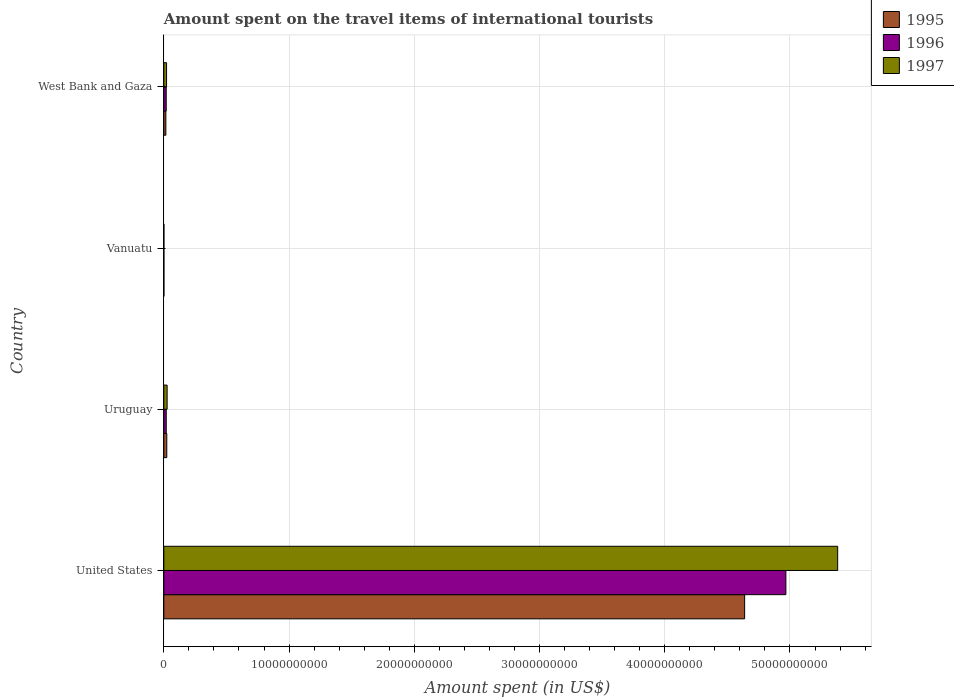How many different coloured bars are there?
Ensure brevity in your answer.  3. Are the number of bars per tick equal to the number of legend labels?
Your answer should be very brief. Yes. Are the number of bars on each tick of the Y-axis equal?
Your answer should be compact. Yes. How many bars are there on the 1st tick from the top?
Keep it short and to the point. 3. How many bars are there on the 4th tick from the bottom?
Provide a short and direct response. 3. What is the amount spent on the travel items of international tourists in 1997 in West Bank and Gaza?
Your answer should be compact. 2.18e+08. Across all countries, what is the maximum amount spent on the travel items of international tourists in 1997?
Make the answer very short. 5.38e+1. In which country was the amount spent on the travel items of international tourists in 1996 maximum?
Offer a very short reply. United States. In which country was the amount spent on the travel items of international tourists in 1995 minimum?
Keep it short and to the point. Vanuatu. What is the total amount spent on the travel items of international tourists in 1996 in the graph?
Provide a succinct answer. 5.01e+1. What is the difference between the amount spent on the travel items of international tourists in 1995 in United States and that in West Bank and Gaza?
Keep it short and to the point. 4.62e+1. What is the difference between the amount spent on the travel items of international tourists in 1995 in Uruguay and the amount spent on the travel items of international tourists in 1996 in Vanuatu?
Your answer should be very brief. 2.31e+08. What is the average amount spent on the travel items of international tourists in 1995 per country?
Your response must be concise. 1.17e+1. What is the difference between the amount spent on the travel items of international tourists in 1996 and amount spent on the travel items of international tourists in 1995 in United States?
Your answer should be compact. 3.29e+09. What is the ratio of the amount spent on the travel items of international tourists in 1997 in United States to that in Vanuatu?
Your response must be concise. 1.08e+04. Is the amount spent on the travel items of international tourists in 1996 in United States less than that in West Bank and Gaza?
Your answer should be very brief. No. What is the difference between the highest and the second highest amount spent on the travel items of international tourists in 1996?
Give a very brief answer. 4.95e+1. What is the difference between the highest and the lowest amount spent on the travel items of international tourists in 1996?
Provide a short and direct response. 4.97e+1. What does the 2nd bar from the top in United States represents?
Offer a very short reply. 1996. What does the 2nd bar from the bottom in Vanuatu represents?
Your answer should be very brief. 1996. Is it the case that in every country, the sum of the amount spent on the travel items of international tourists in 1995 and amount spent on the travel items of international tourists in 1997 is greater than the amount spent on the travel items of international tourists in 1996?
Provide a succinct answer. Yes. How many bars are there?
Ensure brevity in your answer.  12. Are all the bars in the graph horizontal?
Keep it short and to the point. Yes. Where does the legend appear in the graph?
Offer a very short reply. Top right. How many legend labels are there?
Provide a succinct answer. 3. What is the title of the graph?
Give a very brief answer. Amount spent on the travel items of international tourists. Does "1972" appear as one of the legend labels in the graph?
Keep it short and to the point. No. What is the label or title of the X-axis?
Your answer should be very brief. Amount spent (in US$). What is the label or title of the Y-axis?
Give a very brief answer. Country. What is the Amount spent (in US$) in 1995 in United States?
Give a very brief answer. 4.64e+1. What is the Amount spent (in US$) of 1996 in United States?
Offer a terse response. 4.97e+1. What is the Amount spent (in US$) of 1997 in United States?
Make the answer very short. 5.38e+1. What is the Amount spent (in US$) of 1995 in Uruguay?
Keep it short and to the point. 2.36e+08. What is the Amount spent (in US$) in 1996 in Uruguay?
Offer a terse response. 1.92e+08. What is the Amount spent (in US$) in 1997 in Uruguay?
Give a very brief answer. 2.64e+08. What is the Amount spent (in US$) of 1996 in Vanuatu?
Provide a succinct answer. 5.00e+06. What is the Amount spent (in US$) in 1995 in West Bank and Gaza?
Make the answer very short. 1.62e+08. What is the Amount spent (in US$) of 1996 in West Bank and Gaza?
Keep it short and to the point. 1.91e+08. What is the Amount spent (in US$) in 1997 in West Bank and Gaza?
Provide a short and direct response. 2.18e+08. Across all countries, what is the maximum Amount spent (in US$) in 1995?
Provide a succinct answer. 4.64e+1. Across all countries, what is the maximum Amount spent (in US$) of 1996?
Offer a terse response. 4.97e+1. Across all countries, what is the maximum Amount spent (in US$) in 1997?
Your answer should be compact. 5.38e+1. Across all countries, what is the minimum Amount spent (in US$) in 1995?
Offer a very short reply. 5.00e+06. What is the total Amount spent (in US$) in 1995 in the graph?
Make the answer very short. 4.68e+1. What is the total Amount spent (in US$) of 1996 in the graph?
Provide a short and direct response. 5.01e+1. What is the total Amount spent (in US$) in 1997 in the graph?
Your answer should be compact. 5.43e+1. What is the difference between the Amount spent (in US$) of 1995 in United States and that in Uruguay?
Provide a short and direct response. 4.61e+1. What is the difference between the Amount spent (in US$) of 1996 in United States and that in Uruguay?
Your answer should be very brief. 4.95e+1. What is the difference between the Amount spent (in US$) in 1997 in United States and that in Uruguay?
Offer a very short reply. 5.35e+1. What is the difference between the Amount spent (in US$) in 1995 in United States and that in Vanuatu?
Your answer should be very brief. 4.64e+1. What is the difference between the Amount spent (in US$) of 1996 in United States and that in Vanuatu?
Provide a short and direct response. 4.97e+1. What is the difference between the Amount spent (in US$) in 1997 in United States and that in Vanuatu?
Ensure brevity in your answer.  5.38e+1. What is the difference between the Amount spent (in US$) of 1995 in United States and that in West Bank and Gaza?
Give a very brief answer. 4.62e+1. What is the difference between the Amount spent (in US$) in 1996 in United States and that in West Bank and Gaza?
Provide a short and direct response. 4.95e+1. What is the difference between the Amount spent (in US$) in 1997 in United States and that in West Bank and Gaza?
Make the answer very short. 5.36e+1. What is the difference between the Amount spent (in US$) in 1995 in Uruguay and that in Vanuatu?
Offer a terse response. 2.31e+08. What is the difference between the Amount spent (in US$) of 1996 in Uruguay and that in Vanuatu?
Provide a succinct answer. 1.87e+08. What is the difference between the Amount spent (in US$) of 1997 in Uruguay and that in Vanuatu?
Ensure brevity in your answer.  2.59e+08. What is the difference between the Amount spent (in US$) of 1995 in Uruguay and that in West Bank and Gaza?
Offer a very short reply. 7.40e+07. What is the difference between the Amount spent (in US$) in 1996 in Uruguay and that in West Bank and Gaza?
Provide a short and direct response. 1.00e+06. What is the difference between the Amount spent (in US$) in 1997 in Uruguay and that in West Bank and Gaza?
Give a very brief answer. 4.60e+07. What is the difference between the Amount spent (in US$) in 1995 in Vanuatu and that in West Bank and Gaza?
Keep it short and to the point. -1.57e+08. What is the difference between the Amount spent (in US$) of 1996 in Vanuatu and that in West Bank and Gaza?
Your response must be concise. -1.86e+08. What is the difference between the Amount spent (in US$) in 1997 in Vanuatu and that in West Bank and Gaza?
Your answer should be very brief. -2.13e+08. What is the difference between the Amount spent (in US$) in 1995 in United States and the Amount spent (in US$) in 1996 in Uruguay?
Provide a short and direct response. 4.62e+1. What is the difference between the Amount spent (in US$) in 1995 in United States and the Amount spent (in US$) in 1997 in Uruguay?
Give a very brief answer. 4.61e+1. What is the difference between the Amount spent (in US$) in 1996 in United States and the Amount spent (in US$) in 1997 in Uruguay?
Provide a short and direct response. 4.94e+1. What is the difference between the Amount spent (in US$) in 1995 in United States and the Amount spent (in US$) in 1996 in Vanuatu?
Make the answer very short. 4.64e+1. What is the difference between the Amount spent (in US$) in 1995 in United States and the Amount spent (in US$) in 1997 in Vanuatu?
Keep it short and to the point. 4.64e+1. What is the difference between the Amount spent (in US$) of 1996 in United States and the Amount spent (in US$) of 1997 in Vanuatu?
Keep it short and to the point. 4.97e+1. What is the difference between the Amount spent (in US$) in 1995 in United States and the Amount spent (in US$) in 1996 in West Bank and Gaza?
Your response must be concise. 4.62e+1. What is the difference between the Amount spent (in US$) of 1995 in United States and the Amount spent (in US$) of 1997 in West Bank and Gaza?
Provide a short and direct response. 4.62e+1. What is the difference between the Amount spent (in US$) of 1996 in United States and the Amount spent (in US$) of 1997 in West Bank and Gaza?
Keep it short and to the point. 4.95e+1. What is the difference between the Amount spent (in US$) in 1995 in Uruguay and the Amount spent (in US$) in 1996 in Vanuatu?
Offer a very short reply. 2.31e+08. What is the difference between the Amount spent (in US$) of 1995 in Uruguay and the Amount spent (in US$) of 1997 in Vanuatu?
Provide a succinct answer. 2.31e+08. What is the difference between the Amount spent (in US$) in 1996 in Uruguay and the Amount spent (in US$) in 1997 in Vanuatu?
Offer a very short reply. 1.87e+08. What is the difference between the Amount spent (in US$) in 1995 in Uruguay and the Amount spent (in US$) in 1996 in West Bank and Gaza?
Offer a terse response. 4.50e+07. What is the difference between the Amount spent (in US$) in 1995 in Uruguay and the Amount spent (in US$) in 1997 in West Bank and Gaza?
Provide a succinct answer. 1.80e+07. What is the difference between the Amount spent (in US$) in 1996 in Uruguay and the Amount spent (in US$) in 1997 in West Bank and Gaza?
Ensure brevity in your answer.  -2.60e+07. What is the difference between the Amount spent (in US$) in 1995 in Vanuatu and the Amount spent (in US$) in 1996 in West Bank and Gaza?
Ensure brevity in your answer.  -1.86e+08. What is the difference between the Amount spent (in US$) in 1995 in Vanuatu and the Amount spent (in US$) in 1997 in West Bank and Gaza?
Keep it short and to the point. -2.13e+08. What is the difference between the Amount spent (in US$) of 1996 in Vanuatu and the Amount spent (in US$) of 1997 in West Bank and Gaza?
Ensure brevity in your answer.  -2.13e+08. What is the average Amount spent (in US$) in 1995 per country?
Give a very brief answer. 1.17e+1. What is the average Amount spent (in US$) in 1996 per country?
Make the answer very short. 1.25e+1. What is the average Amount spent (in US$) of 1997 per country?
Provide a succinct answer. 1.36e+1. What is the difference between the Amount spent (in US$) in 1995 and Amount spent (in US$) in 1996 in United States?
Make the answer very short. -3.29e+09. What is the difference between the Amount spent (in US$) in 1995 and Amount spent (in US$) in 1997 in United States?
Provide a succinct answer. -7.43e+09. What is the difference between the Amount spent (in US$) in 1996 and Amount spent (in US$) in 1997 in United States?
Provide a succinct answer. -4.14e+09. What is the difference between the Amount spent (in US$) in 1995 and Amount spent (in US$) in 1996 in Uruguay?
Provide a succinct answer. 4.40e+07. What is the difference between the Amount spent (in US$) of 1995 and Amount spent (in US$) of 1997 in Uruguay?
Your response must be concise. -2.80e+07. What is the difference between the Amount spent (in US$) in 1996 and Amount spent (in US$) in 1997 in Uruguay?
Give a very brief answer. -7.20e+07. What is the difference between the Amount spent (in US$) in 1995 and Amount spent (in US$) in 1996 in West Bank and Gaza?
Make the answer very short. -2.90e+07. What is the difference between the Amount spent (in US$) in 1995 and Amount spent (in US$) in 1997 in West Bank and Gaza?
Provide a short and direct response. -5.60e+07. What is the difference between the Amount spent (in US$) of 1996 and Amount spent (in US$) of 1997 in West Bank and Gaza?
Provide a succinct answer. -2.70e+07. What is the ratio of the Amount spent (in US$) in 1995 in United States to that in Uruguay?
Offer a very short reply. 196.52. What is the ratio of the Amount spent (in US$) in 1996 in United States to that in Uruguay?
Keep it short and to the point. 258.71. What is the ratio of the Amount spent (in US$) in 1997 in United States to that in Uruguay?
Keep it short and to the point. 203.82. What is the ratio of the Amount spent (in US$) in 1995 in United States to that in Vanuatu?
Provide a short and direct response. 9275.8. What is the ratio of the Amount spent (in US$) in 1996 in United States to that in Vanuatu?
Provide a succinct answer. 9934.4. What is the ratio of the Amount spent (in US$) of 1997 in United States to that in Vanuatu?
Make the answer very short. 1.08e+04. What is the ratio of the Amount spent (in US$) in 1995 in United States to that in West Bank and Gaza?
Give a very brief answer. 286.29. What is the ratio of the Amount spent (in US$) in 1996 in United States to that in West Bank and Gaza?
Provide a succinct answer. 260.06. What is the ratio of the Amount spent (in US$) of 1997 in United States to that in West Bank and Gaza?
Make the answer very short. 246.83. What is the ratio of the Amount spent (in US$) of 1995 in Uruguay to that in Vanuatu?
Ensure brevity in your answer.  47.2. What is the ratio of the Amount spent (in US$) in 1996 in Uruguay to that in Vanuatu?
Provide a succinct answer. 38.4. What is the ratio of the Amount spent (in US$) in 1997 in Uruguay to that in Vanuatu?
Provide a succinct answer. 52.8. What is the ratio of the Amount spent (in US$) of 1995 in Uruguay to that in West Bank and Gaza?
Make the answer very short. 1.46. What is the ratio of the Amount spent (in US$) in 1997 in Uruguay to that in West Bank and Gaza?
Give a very brief answer. 1.21. What is the ratio of the Amount spent (in US$) in 1995 in Vanuatu to that in West Bank and Gaza?
Provide a short and direct response. 0.03. What is the ratio of the Amount spent (in US$) of 1996 in Vanuatu to that in West Bank and Gaza?
Give a very brief answer. 0.03. What is the ratio of the Amount spent (in US$) of 1997 in Vanuatu to that in West Bank and Gaza?
Give a very brief answer. 0.02. What is the difference between the highest and the second highest Amount spent (in US$) in 1995?
Your answer should be very brief. 4.61e+1. What is the difference between the highest and the second highest Amount spent (in US$) in 1996?
Your answer should be very brief. 4.95e+1. What is the difference between the highest and the second highest Amount spent (in US$) in 1997?
Give a very brief answer. 5.35e+1. What is the difference between the highest and the lowest Amount spent (in US$) in 1995?
Your answer should be very brief. 4.64e+1. What is the difference between the highest and the lowest Amount spent (in US$) in 1996?
Your response must be concise. 4.97e+1. What is the difference between the highest and the lowest Amount spent (in US$) in 1997?
Make the answer very short. 5.38e+1. 